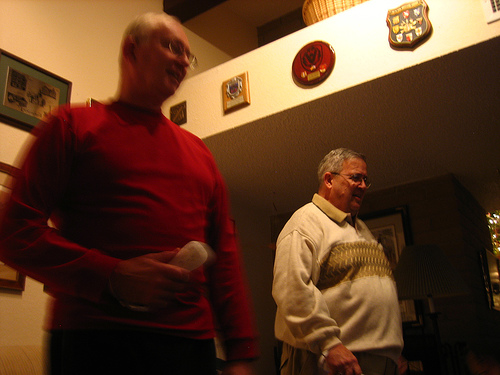Are there both remote controls and beds in the picture? There is indeed a remote control in the image; however, no beds are visible in the setting. 